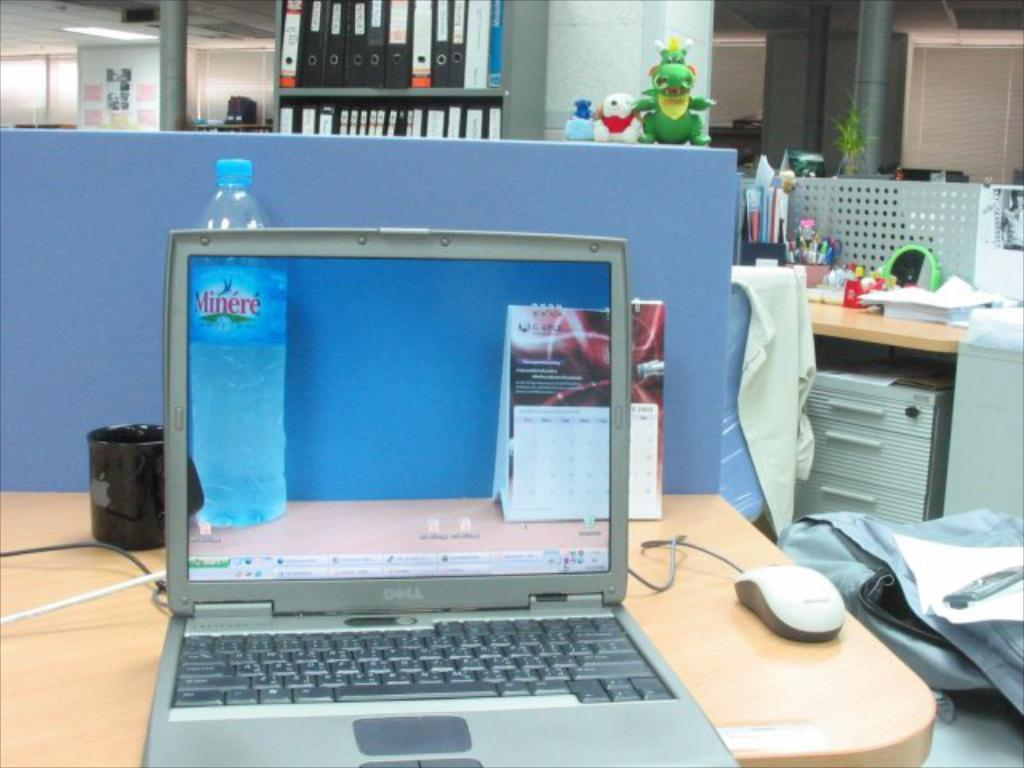<image>
Offer a succinct explanation of the picture presented. A Dell laptop computer is on a desk with the top open. 